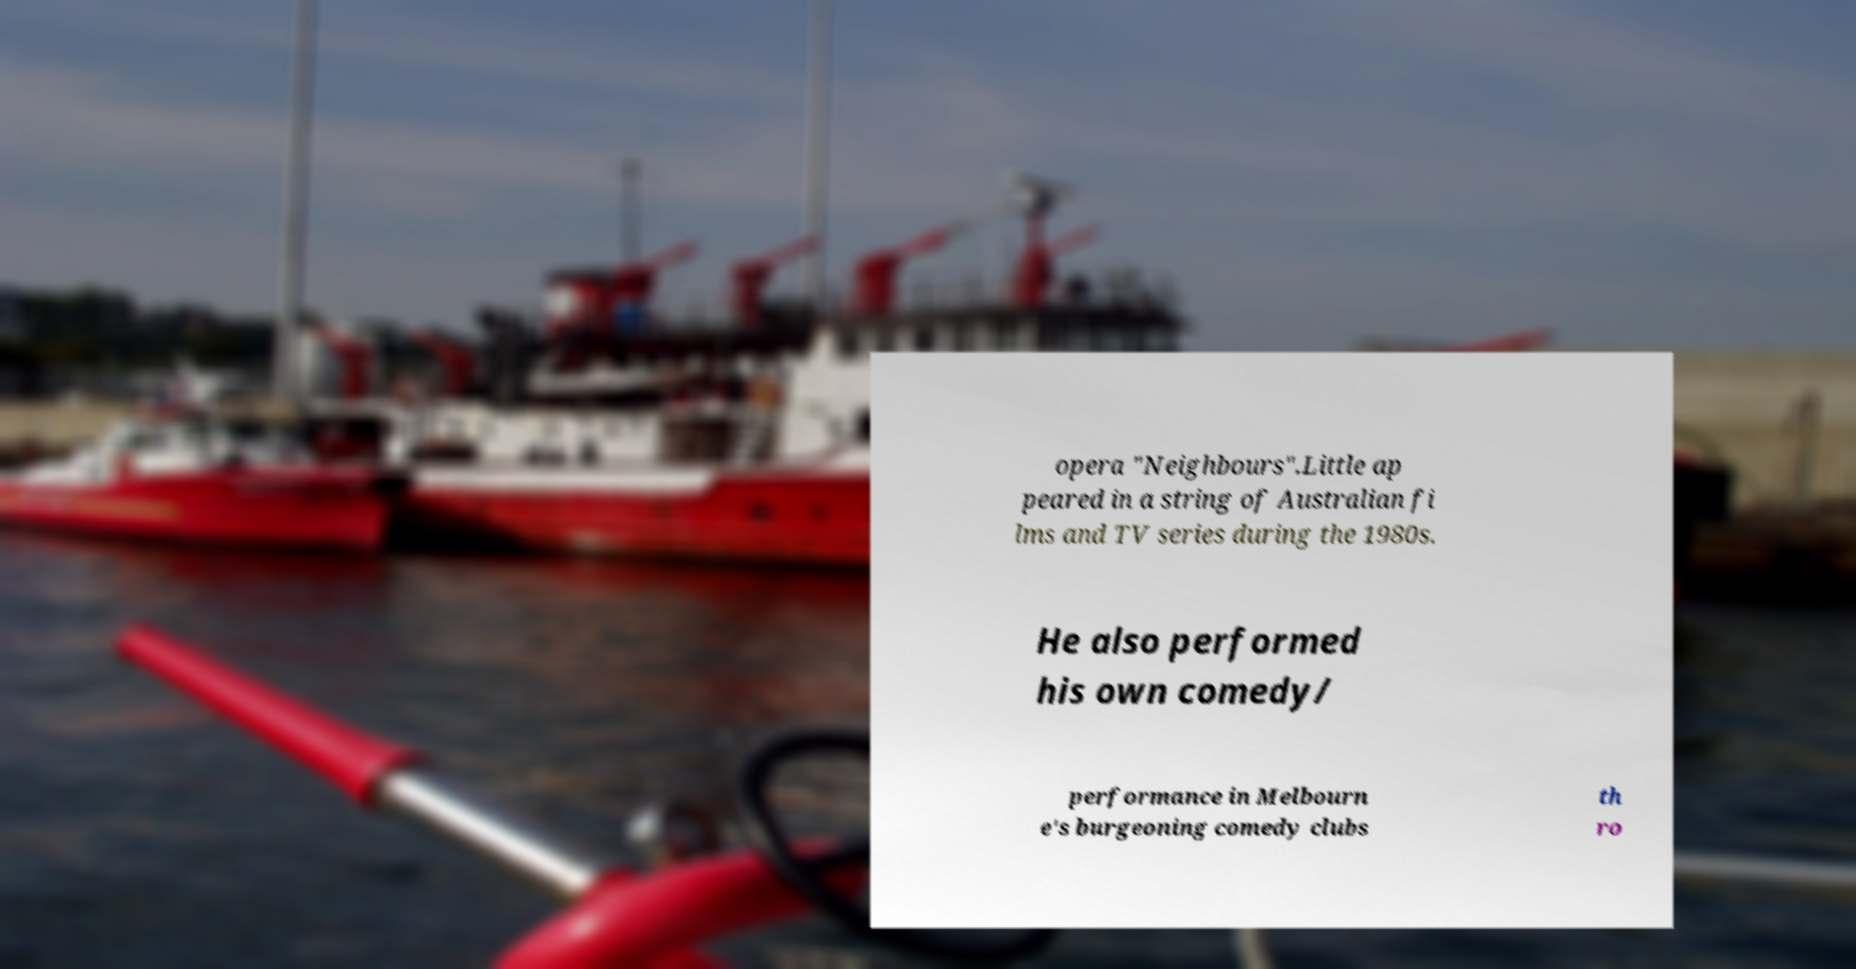Can you read and provide the text displayed in the image?This photo seems to have some interesting text. Can you extract and type it out for me? opera "Neighbours".Little ap peared in a string of Australian fi lms and TV series during the 1980s. He also performed his own comedy/ performance in Melbourn e's burgeoning comedy clubs th ro 